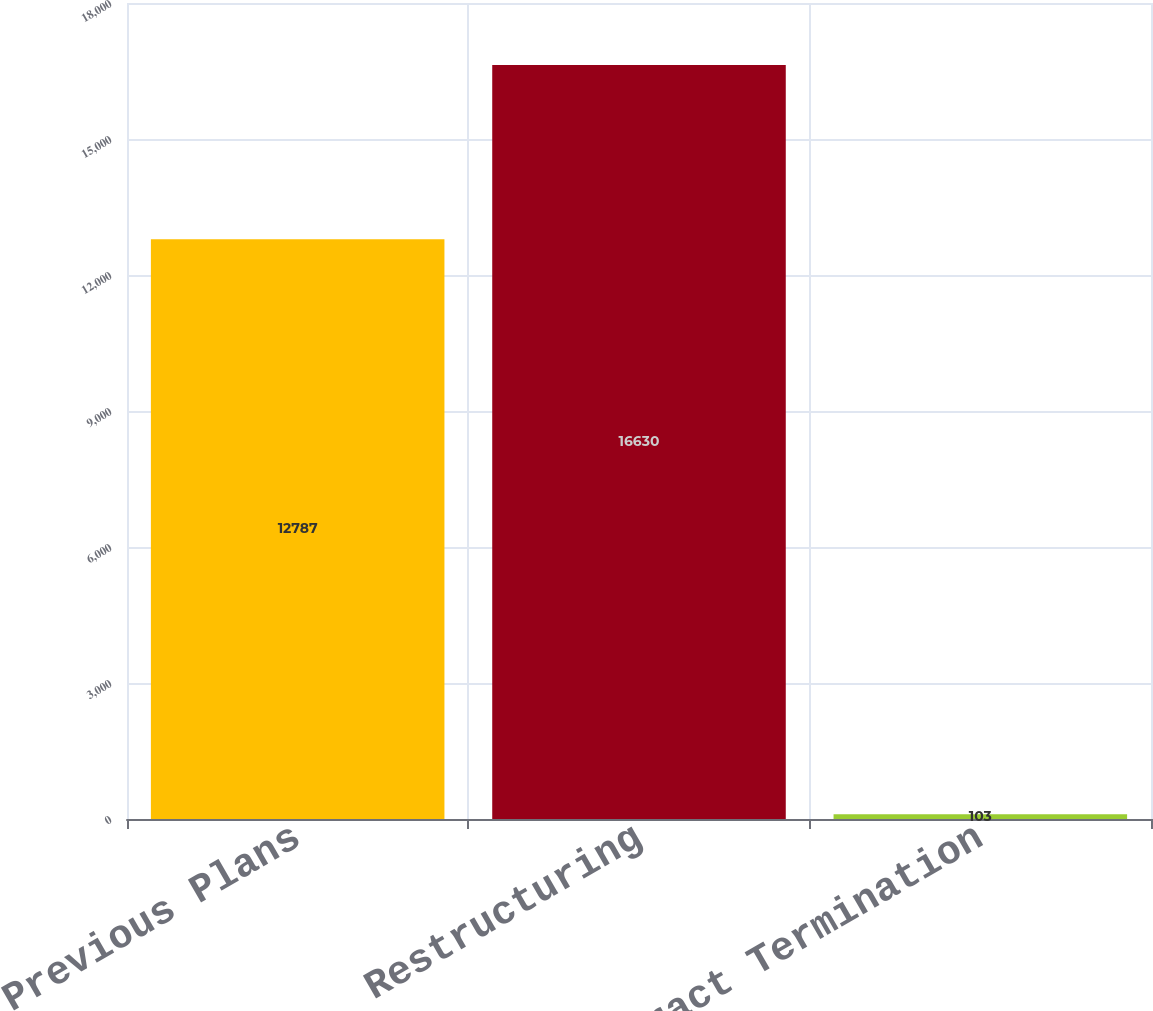Convert chart to OTSL. <chart><loc_0><loc_0><loc_500><loc_500><bar_chart><fcel>Previous Plans<fcel>Restructuring<fcel>Contract Termination<nl><fcel>12787<fcel>16630<fcel>103<nl></chart> 